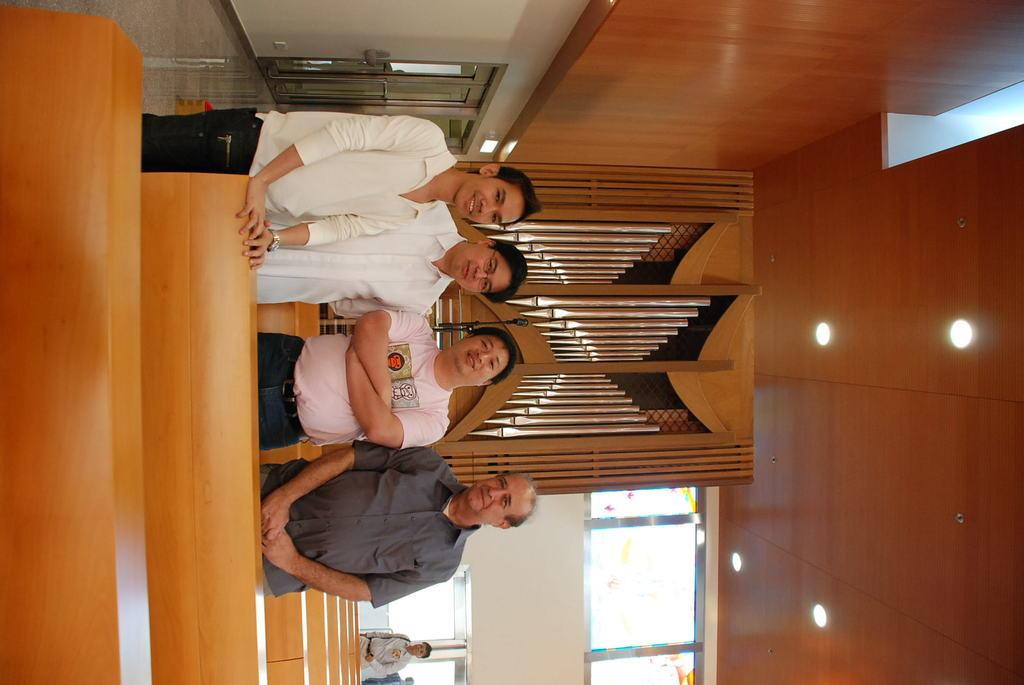What are the people in the image doing? The people in the image are standing on the ground. What type of seating is available in the image? There are benches in the image. Can you describe the person in the background of the image? There is another person standing in the background of the image. What can be seen in the image that provides illumination? There are lightings visible in the image. What decision does the hen make in the image? There is no hen present in the image, so no decision can be made by a hen. 